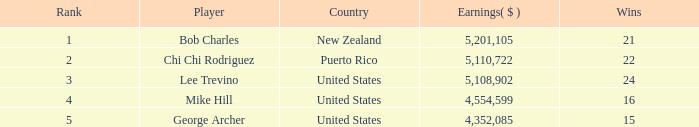Typically, how many victories hold a ranking less than 1? None. Can you parse all the data within this table? {'header': ['Rank', 'Player', 'Country', 'Earnings( $ )', 'Wins'], 'rows': [['1', 'Bob Charles', 'New Zealand', '5,201,105', '21'], ['2', 'Chi Chi Rodriguez', 'Puerto Rico', '5,110,722', '22'], ['3', 'Lee Trevino', 'United States', '5,108,902', '24'], ['4', 'Mike Hill', 'United States', '4,554,599', '16'], ['5', 'George Archer', 'United States', '4,352,085', '15']]} 